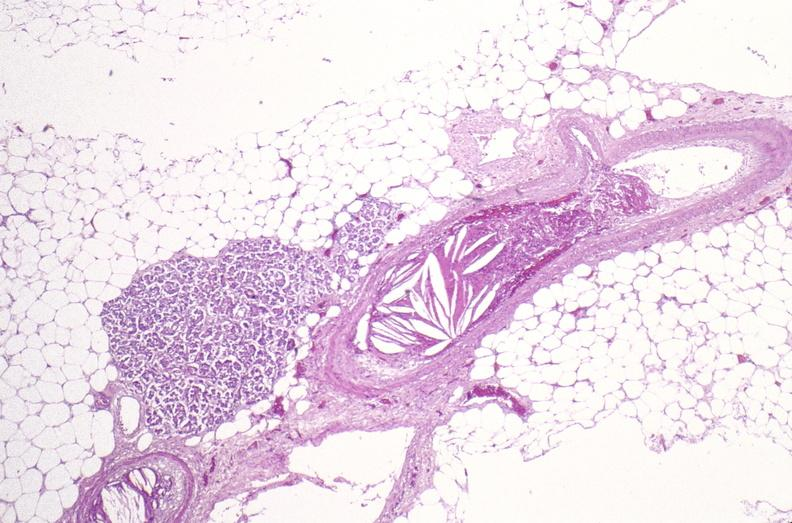does this image show atherosclerotic emboli?
Answer the question using a single word or phrase. Yes 